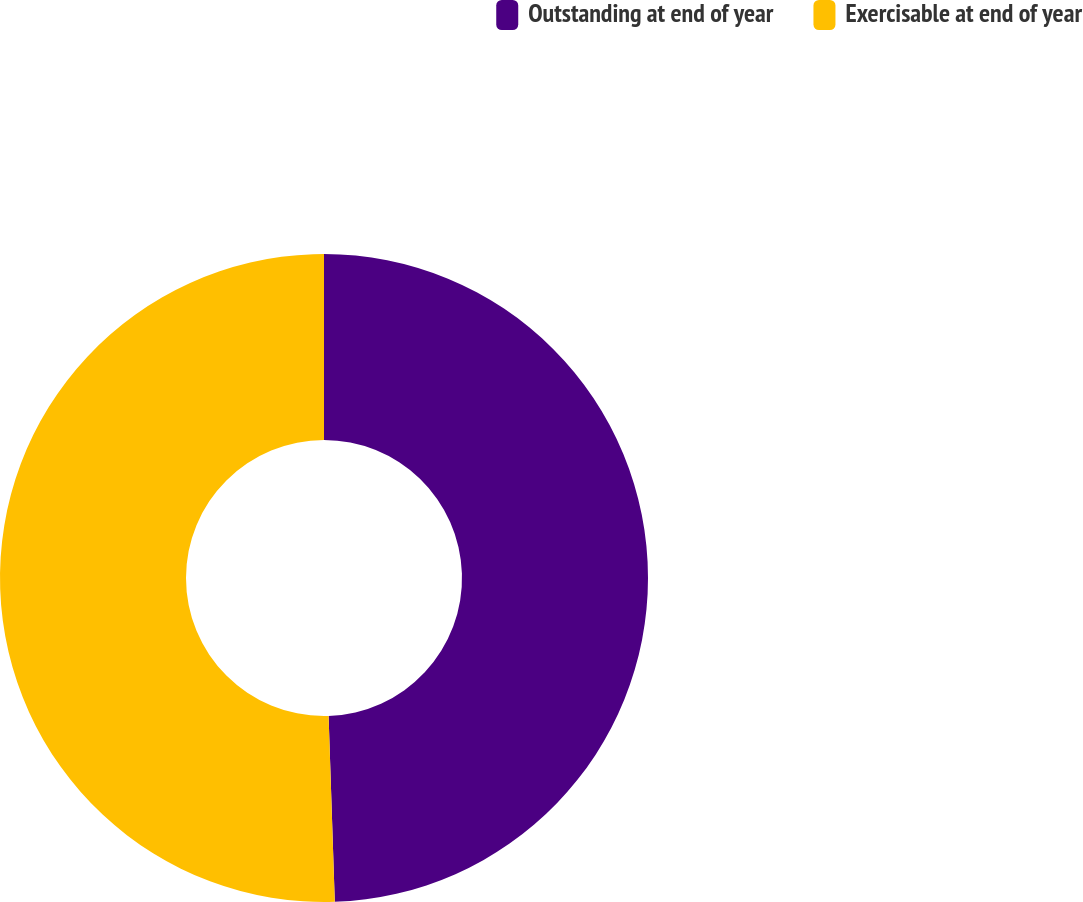<chart> <loc_0><loc_0><loc_500><loc_500><pie_chart><fcel>Outstanding at end of year<fcel>Exercisable at end of year<nl><fcel>49.47%<fcel>50.53%<nl></chart> 